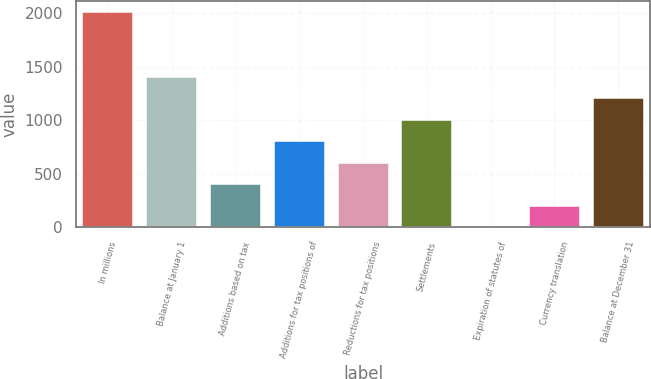<chart> <loc_0><loc_0><loc_500><loc_500><bar_chart><fcel>In millions<fcel>Balance at January 1<fcel>Additions based on tax<fcel>Additions for tax positions of<fcel>Reductions for tax positions<fcel>Settlements<fcel>Expiration of statutes of<fcel>Currency translation<fcel>Balance at December 31<nl><fcel>2009<fcel>1406.9<fcel>403.4<fcel>804.8<fcel>604.1<fcel>1005.5<fcel>2<fcel>202.7<fcel>1206.2<nl></chart> 